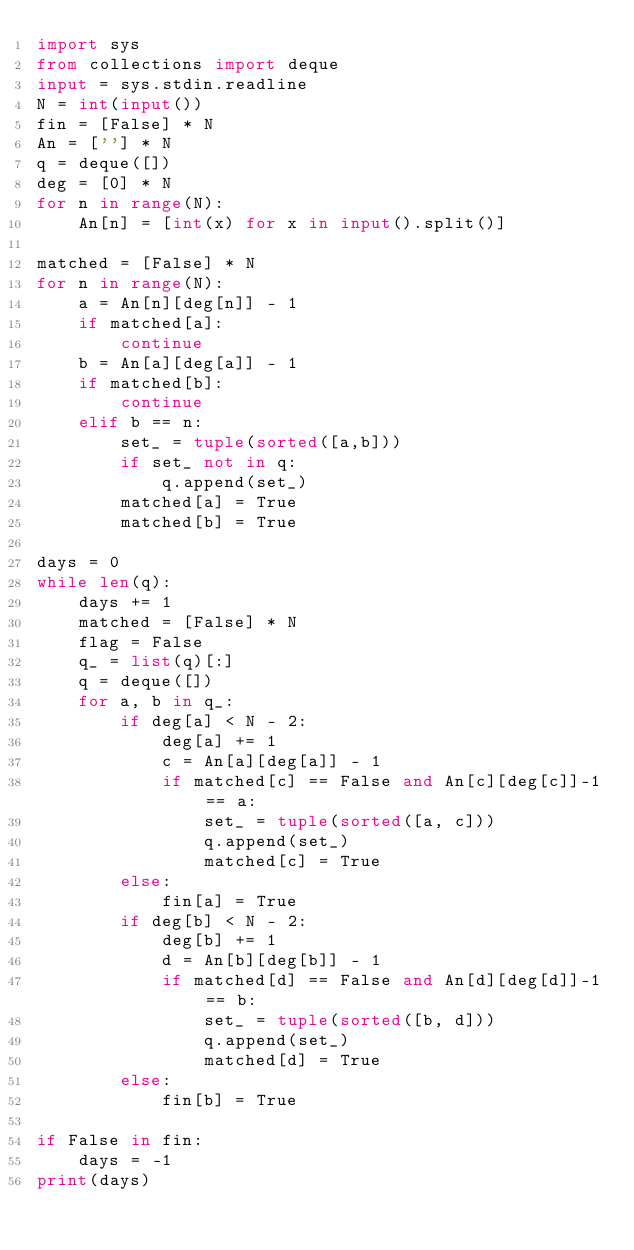<code> <loc_0><loc_0><loc_500><loc_500><_Python_>import sys
from collections import deque
input = sys.stdin.readline
N = int(input())
fin = [False] * N
An = [''] * N
q = deque([])
deg = [0] * N
for n in range(N):
    An[n] = [int(x) for x in input().split()]

matched = [False] * N
for n in range(N):
    a = An[n][deg[n]] - 1
    if matched[a]:
        continue
    b = An[a][deg[a]] - 1
    if matched[b]:
        continue
    elif b == n:
        set_ = tuple(sorted([a,b]))
        if set_ not in q:
            q.append(set_)
        matched[a] = True
        matched[b] = True

days = 0
while len(q):
    days += 1
    matched = [False] * N
    flag = False
    q_ = list(q)[:]
    q = deque([])
    for a, b in q_:
        if deg[a] < N - 2:
            deg[a] += 1
            c = An[a][deg[a]] - 1
            if matched[c] == False and An[c][deg[c]]-1 == a:
                set_ = tuple(sorted([a, c]))
                q.append(set_)
                matched[c] = True
        else:
            fin[a] = True
        if deg[b] < N - 2:
            deg[b] += 1
            d = An[b][deg[b]] - 1
            if matched[d] == False and An[d][deg[d]]-1 == b:
                set_ = tuple(sorted([b, d]))
                q.append(set_)
                matched[d] = True
        else:
            fin[b] = True

if False in fin:
    days = -1
print(days)</code> 